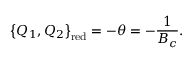<formula> <loc_0><loc_0><loc_500><loc_500>\left \{ Q _ { 1 } , Q _ { 2 } \right \} _ { r e d } = - \theta = - \frac { 1 } { B _ { c } } .</formula> 